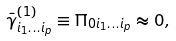Convert formula to latex. <formula><loc_0><loc_0><loc_500><loc_500>\bar { \gamma } _ { i _ { 1 } \dots i _ { p } } ^ { ( 1 ) } \equiv \Pi _ { 0 i _ { 1 } \dots i _ { p } } \approx 0 ,</formula> 